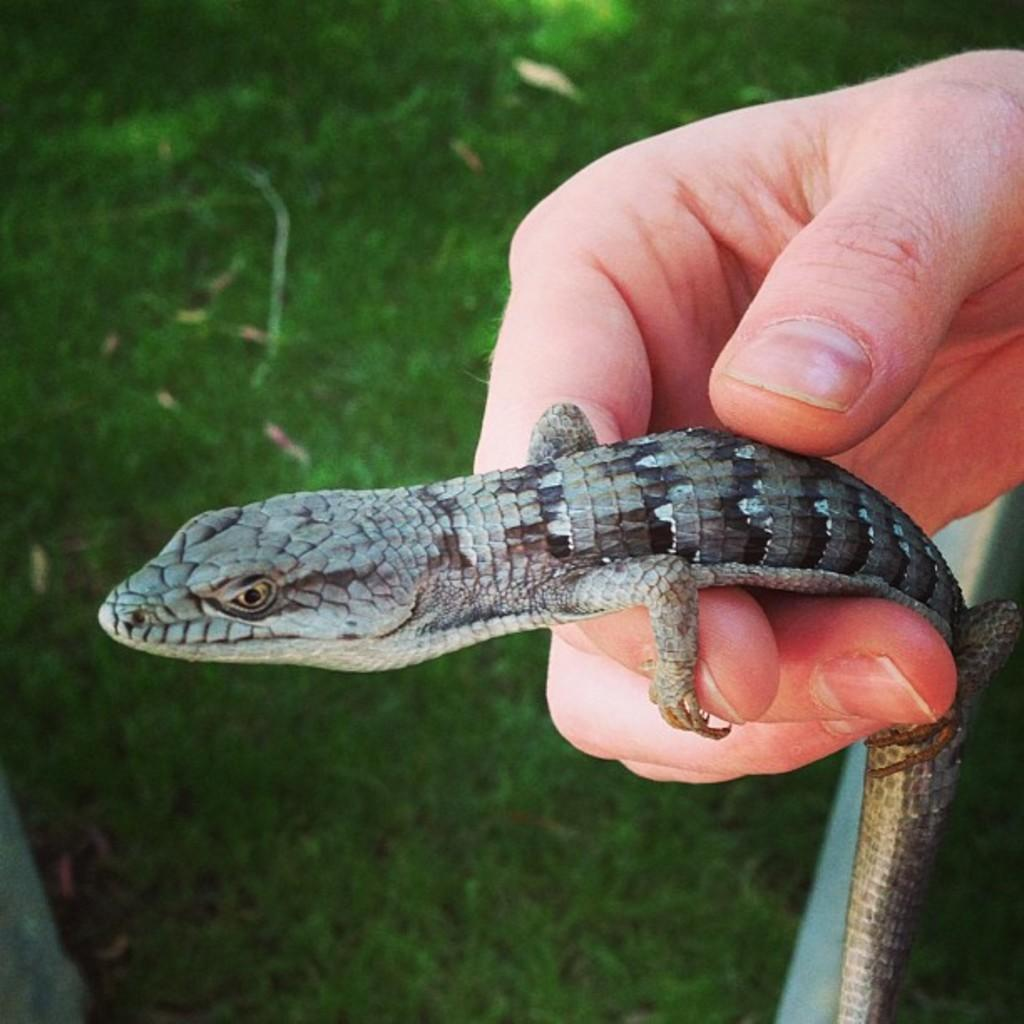What can be seen in the image? There is a person's hand in the image. What is the person's hand holding? The person's hand is holding an alligator. What type of voice can be heard coming from the alligator in the image? There is no sound or voice present in the image, as it is a still image. 